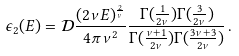<formula> <loc_0><loc_0><loc_500><loc_500>\epsilon _ { 2 } ( E ) = { \mathcal { D } } \frac { ( 2 \nu E ) ^ { \frac { 2 } { \nu } } } { 4 \pi \nu ^ { 2 } } \frac { \Gamma ( \frac { 1 } { 2 \nu } ) \Gamma ( \frac { 3 } { 2 \nu } ) } { \Gamma ( \frac { \nu + 1 } { 2 \nu } ) \Gamma ( \frac { 3 \nu + 3 } { 2 \nu } ) } \, .</formula> 